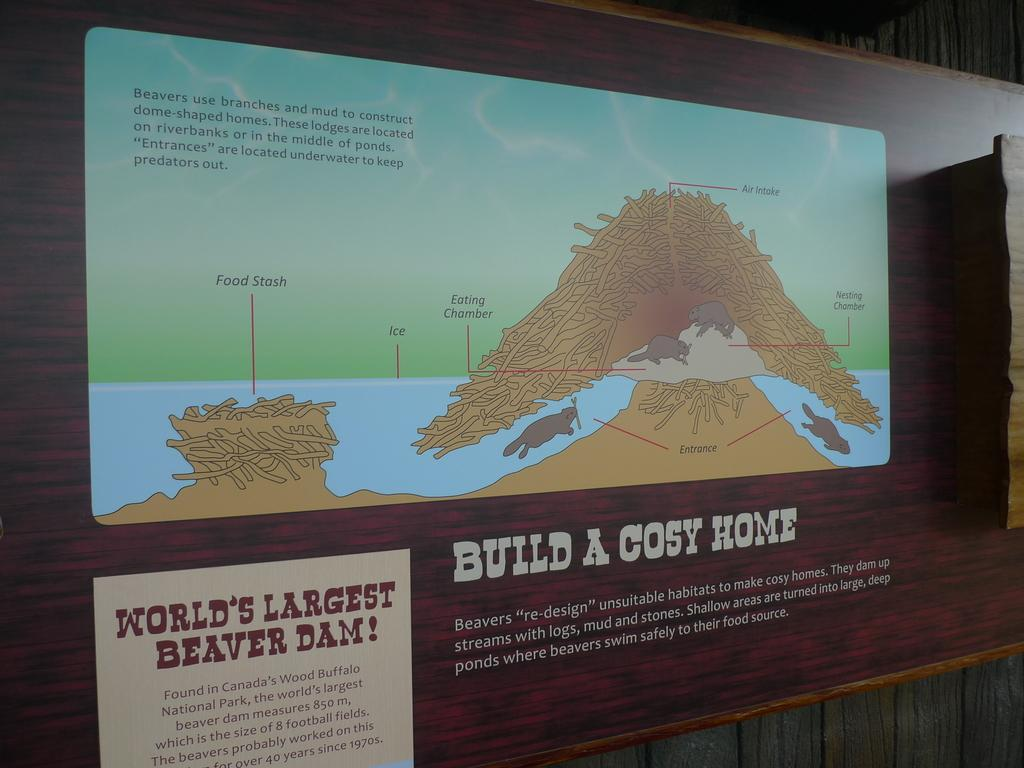<image>
Write a terse but informative summary of the picture. A picture of a diagram for the worlds largest Beaver Dam. 